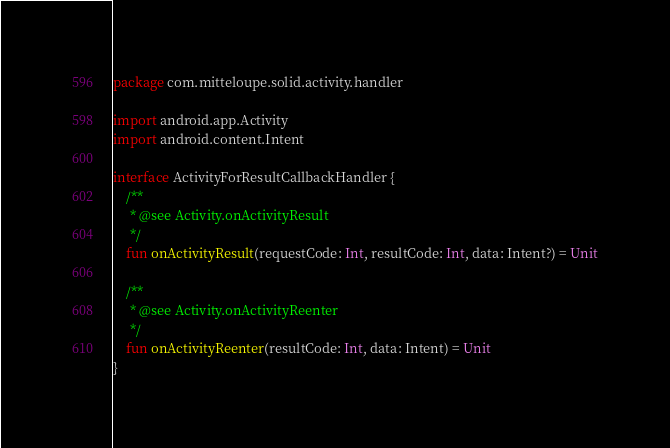<code> <loc_0><loc_0><loc_500><loc_500><_Kotlin_>package com.mitteloupe.solid.activity.handler

import android.app.Activity
import android.content.Intent

interface ActivityForResultCallbackHandler {
    /**
     * @see Activity.onActivityResult
     */
    fun onActivityResult(requestCode: Int, resultCode: Int, data: Intent?) = Unit

    /**
     * @see Activity.onActivityReenter
     */
    fun onActivityReenter(resultCode: Int, data: Intent) = Unit
}
</code> 